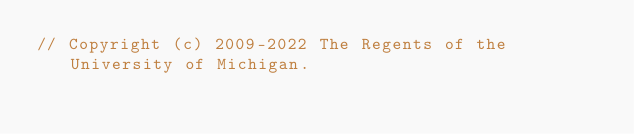<code> <loc_0><loc_0><loc_500><loc_500><_Cuda_>// Copyright (c) 2009-2022 The Regents of the University of Michigan.</code> 